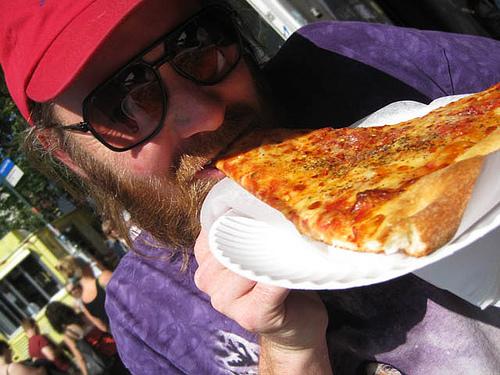What is the man eating?
Write a very short answer. Pizza. Is the man eating?
Quick response, please. Yes. Is it sunny out?
Quick response, please. Yes. 